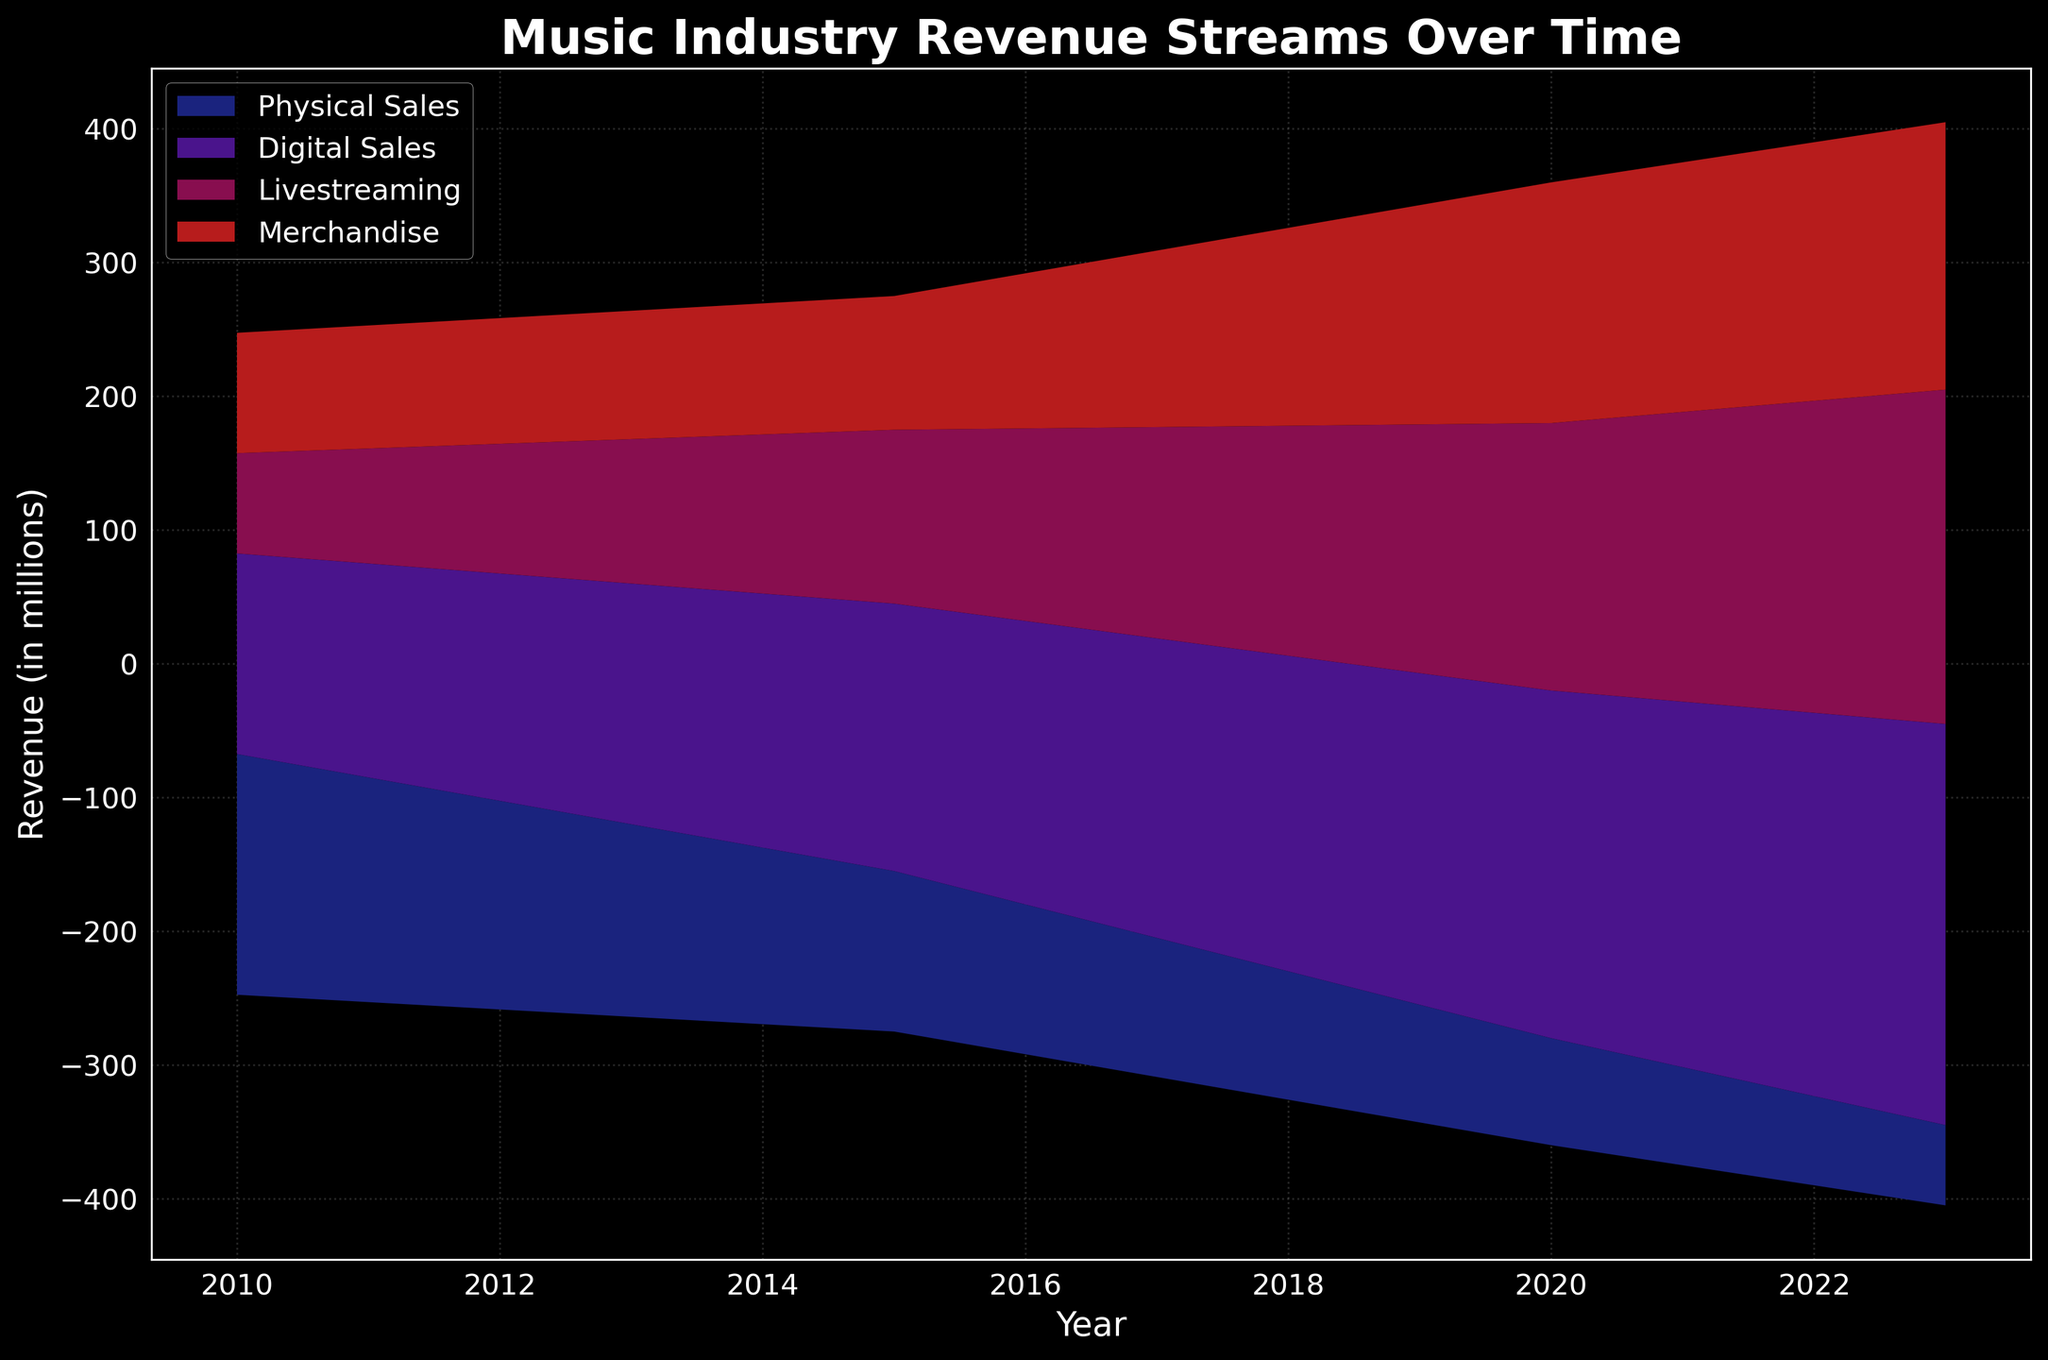What's the title of the chart? The title of the chart is typically located at the top and summarizes what the chart represents. In this case, it reads "Music Industry Revenue Streams Over Time".
Answer: Music Industry Revenue Streams Over Time What is the x-axis representing? The x-axis runs horizontally at the bottom of the chart and indicates the different years for which data is being shown. You can see tick marks and labels along this axis such as 2010, 2015, 2020, and 2023.
Answer: Year What does the y-axis measure? The y-axis runs vertically along the left side of the chart and measures the revenue in millions of dollars. This can be inferred from the label beside the axis which reads "Revenue (in millions)".
Answer: Revenue (in millions) Which artist had the highest revenue in 2020? To determine this, look for the annotation on the chart at the 2020 marker along the x-axis. The annotated text there shows the top artist for that year.
Answer: Drake What were the major revenue streams contributing to the total revenue in 2015? Observing the stacked areas in 2015 on the x-axis, you can identify the layers and their colors that correspond to different revenue streams denoted in the legend. The significant streams were Physical Sales, Digital Sales, Livestreaming, and Merchandise.
Answer: Physical Sales, Digital Sales, Livestreaming, Merchandise How did the revenue from Digital Sales change between 2010 and 2023? Identify the layers representing Digital Sales at 2010 and 2023 from their colors in the stack. Compare their heights to observe the increasing trend over the years.
Answer: Increased Who were the top artists in the years given? Examine the annotations for each year on the x-axis where the top artist for that year is mentioned. For example, in 2010 it's Lady Gaga, and for 2023 it's BTS. Summarize the artists for all years mentioned.
Answer: 2010: Lady Gaga, 2015: Adele, 2020: Drake, 2023: BTS Compare the revenue from Physical Sales and Livestreaming in 2020. Which is higher, and by how much? Look at the heights of the respective sections of the stacks for Physical Sales and Livestreaming at the 2020 marker. Calculate the difference between them.
Answer: Livestreaming is higher by 120 million Which year saw the highest total revenue? To determine this, sum the height of the stack for each year along the x-axis and identify the year with the tallest stack visually.
Answer: 2023 